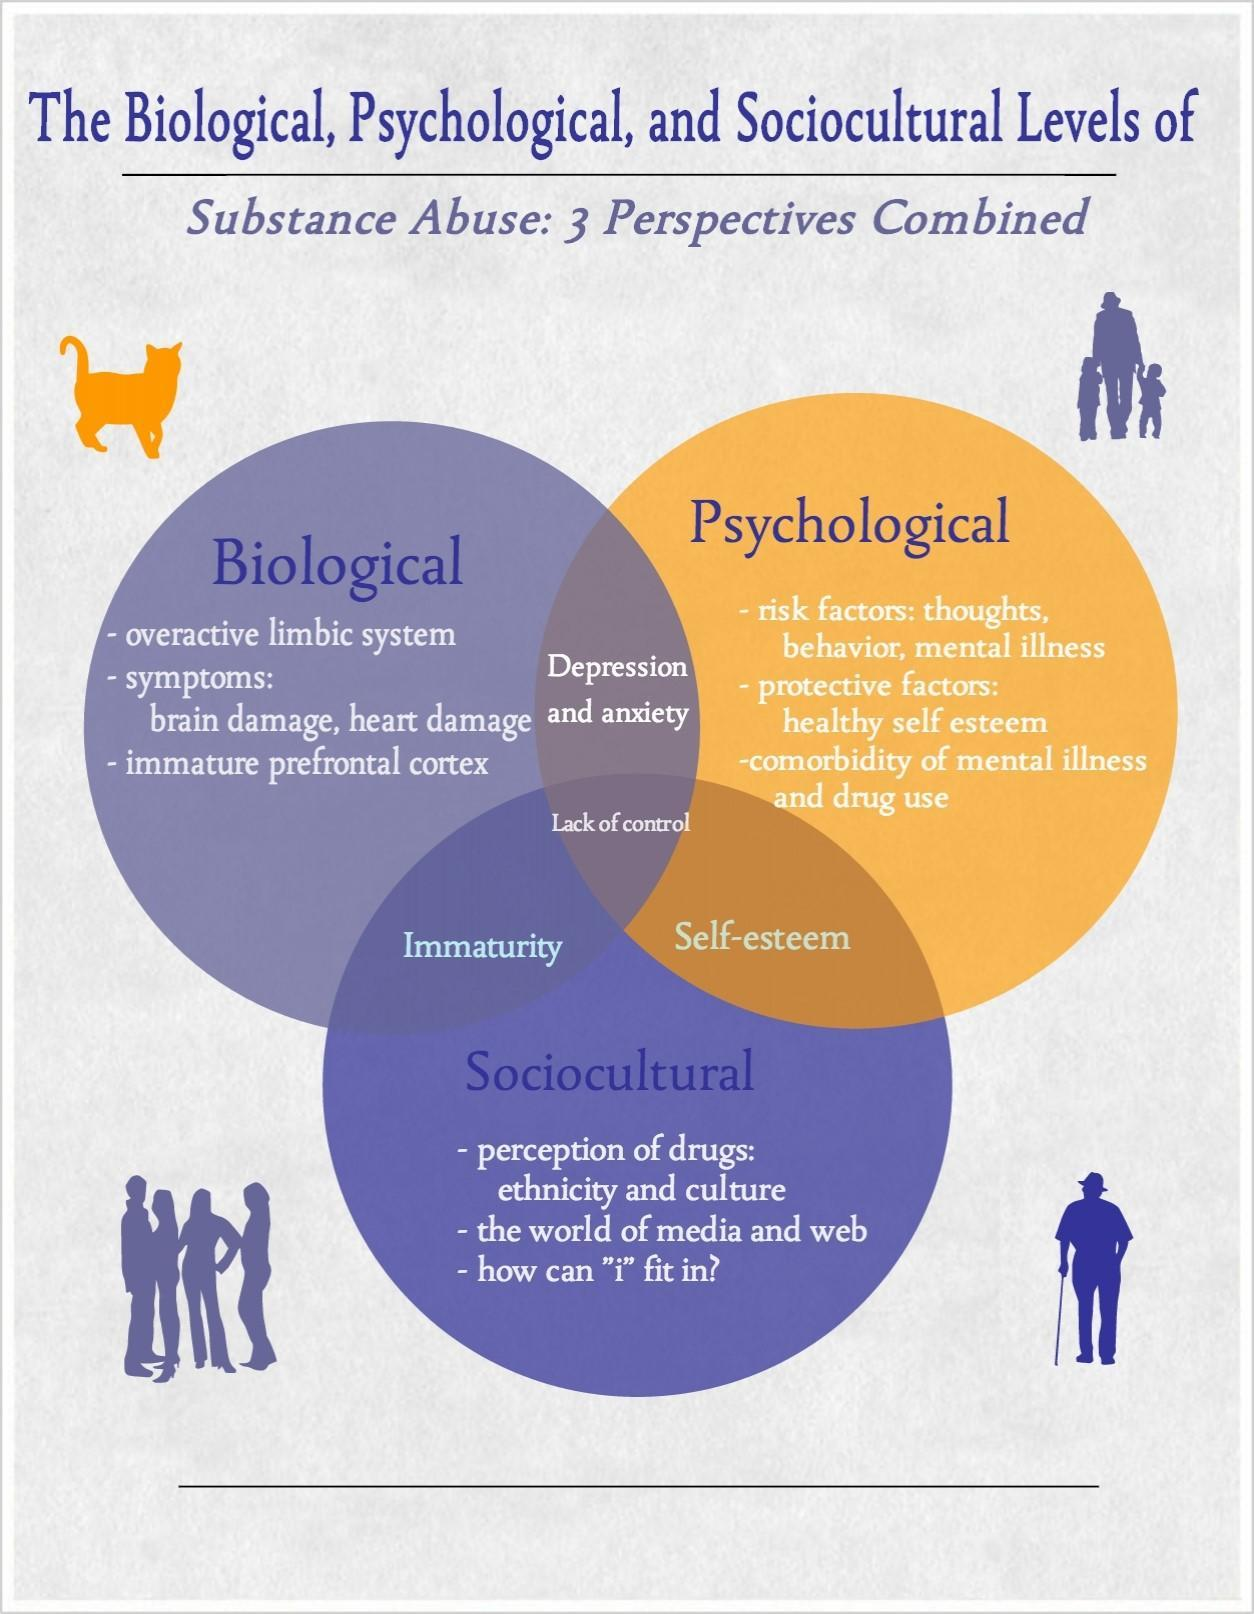What emerges as the main cause of substance abuse from Biological, Sociocultural, and Psycological perspectives?
Answer the question with a short phrase. Lack of control Which emerges as a cause for substance abuse due to the intersection of Biological and Psychological perspective ? Depression and anxiety What emerges as the cause for substance abuse due to Sociocultural and Biological perspectives? Immaturity What emerges as the cause for substance abuse due to Sociocultural and Psycological perspectives? Self Esteem 